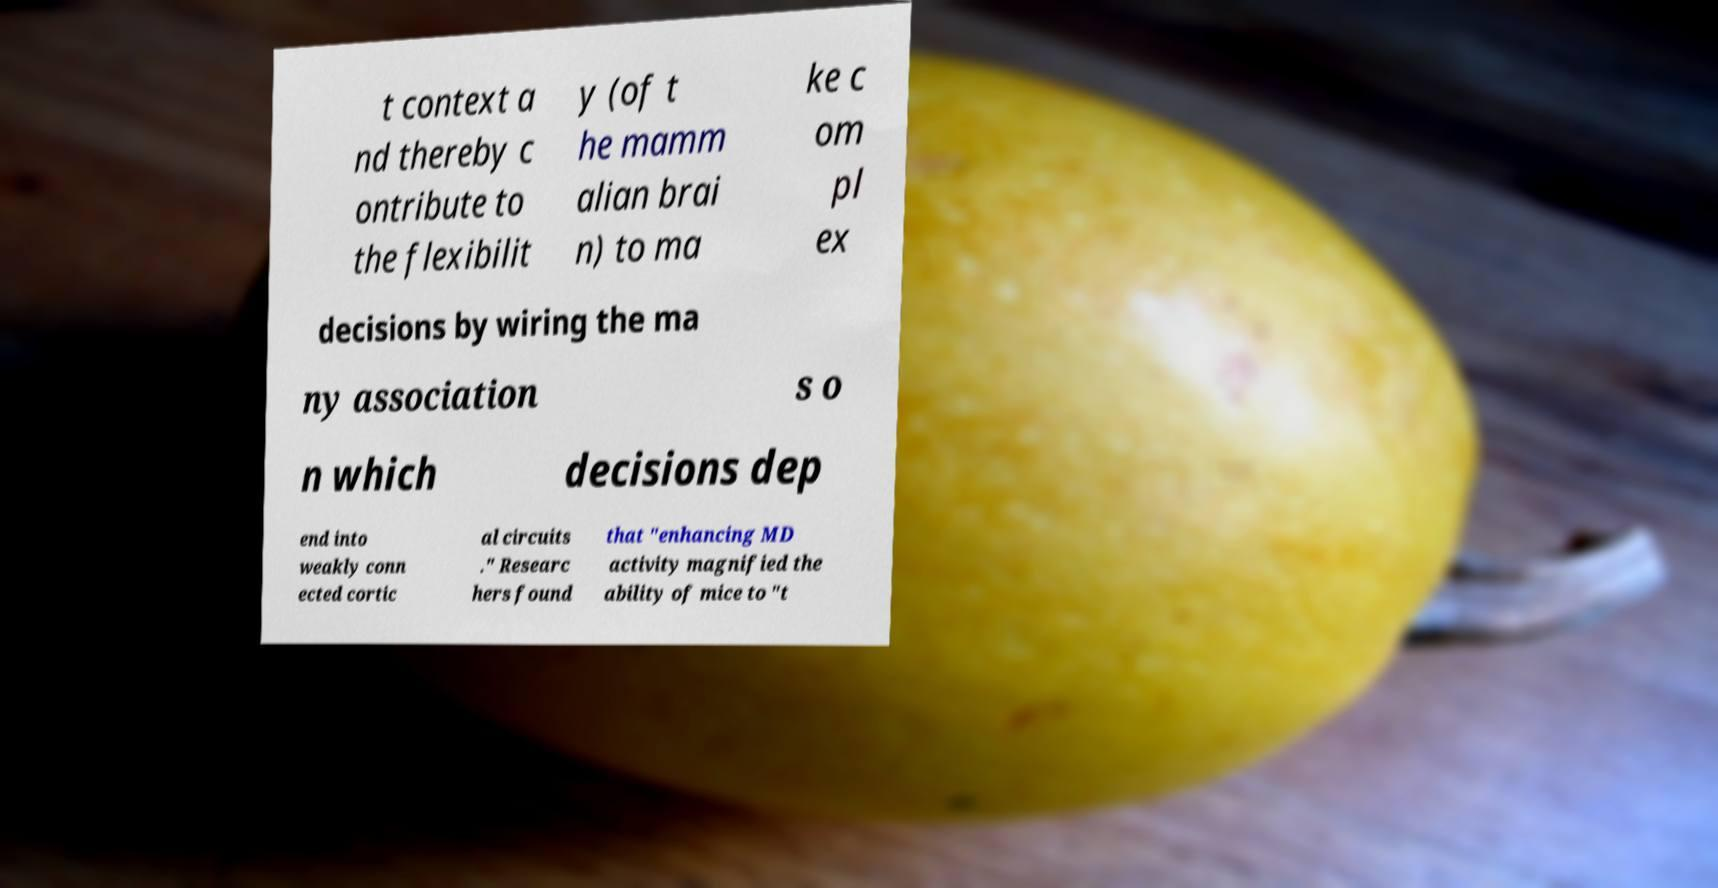What messages or text are displayed in this image? I need them in a readable, typed format. t context a nd thereby c ontribute to the flexibilit y (of t he mamm alian brai n) to ma ke c om pl ex decisions by wiring the ma ny association s o n which decisions dep end into weakly conn ected cortic al circuits ." Researc hers found that "enhancing MD activity magnified the ability of mice to "t 